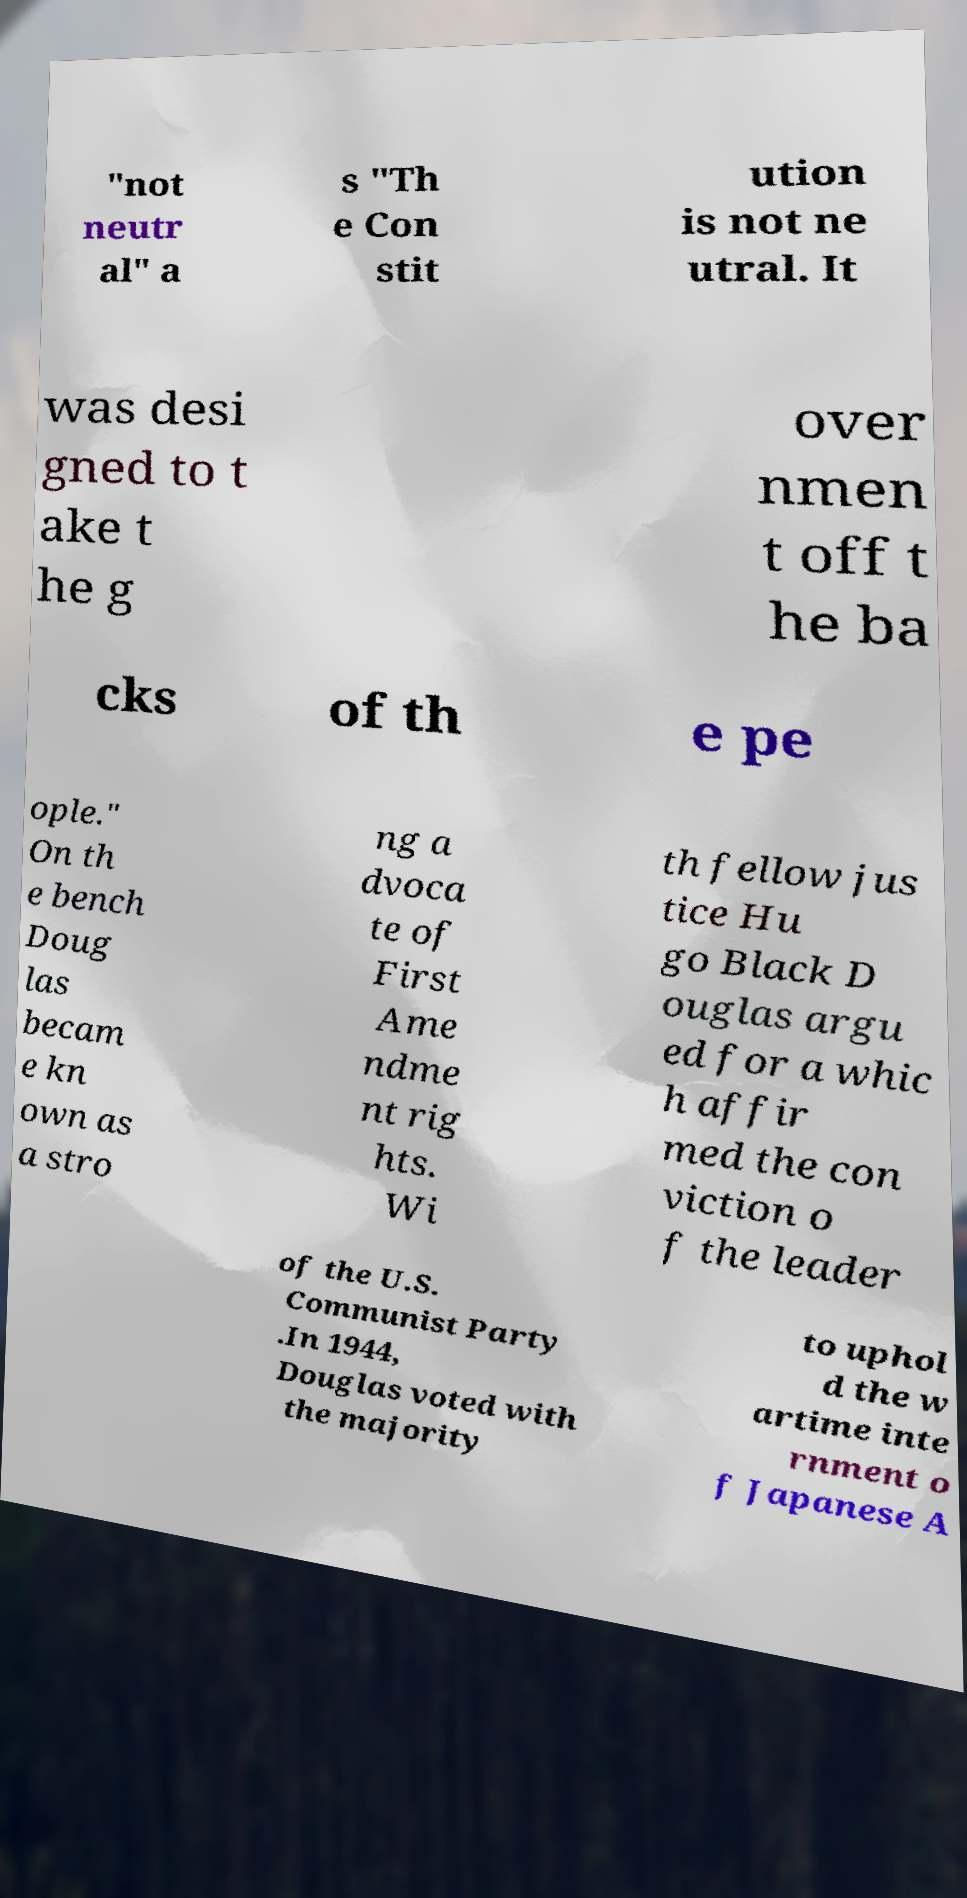Could you extract and type out the text from this image? "not neutr al" a s "Th e Con stit ution is not ne utral. It was desi gned to t ake t he g over nmen t off t he ba cks of th e pe ople." On th e bench Doug las becam e kn own as a stro ng a dvoca te of First Ame ndme nt rig hts. Wi th fellow jus tice Hu go Black D ouglas argu ed for a whic h affir med the con viction o f the leader of the U.S. Communist Party .In 1944, Douglas voted with the majority to uphol d the w artime inte rnment o f Japanese A 